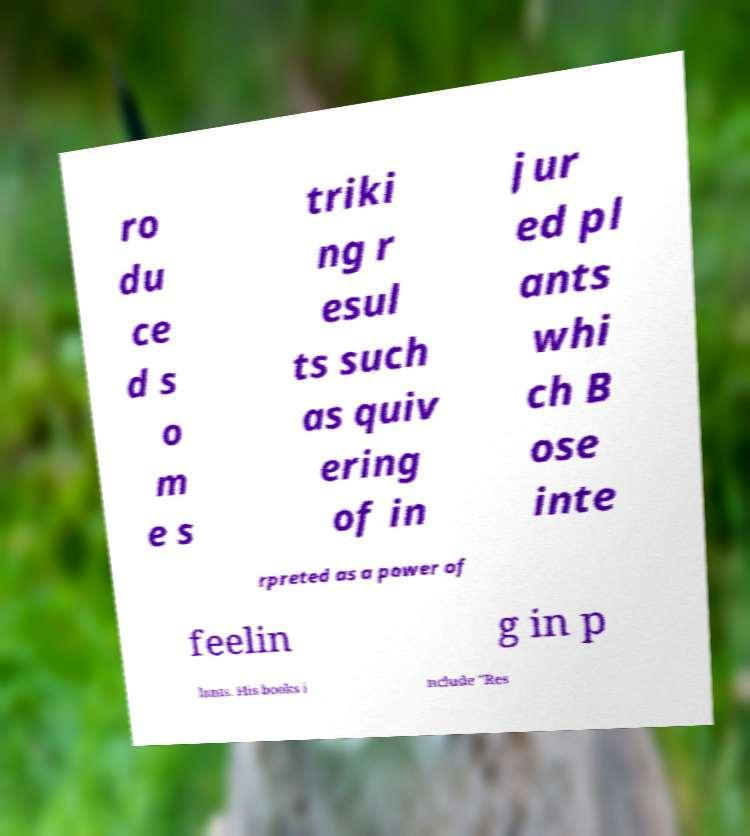I need the written content from this picture converted into text. Can you do that? ro du ce d s o m e s triki ng r esul ts such as quiv ering of in jur ed pl ants whi ch B ose inte rpreted as a power of feelin g in p lants. His books i nclude "Res 